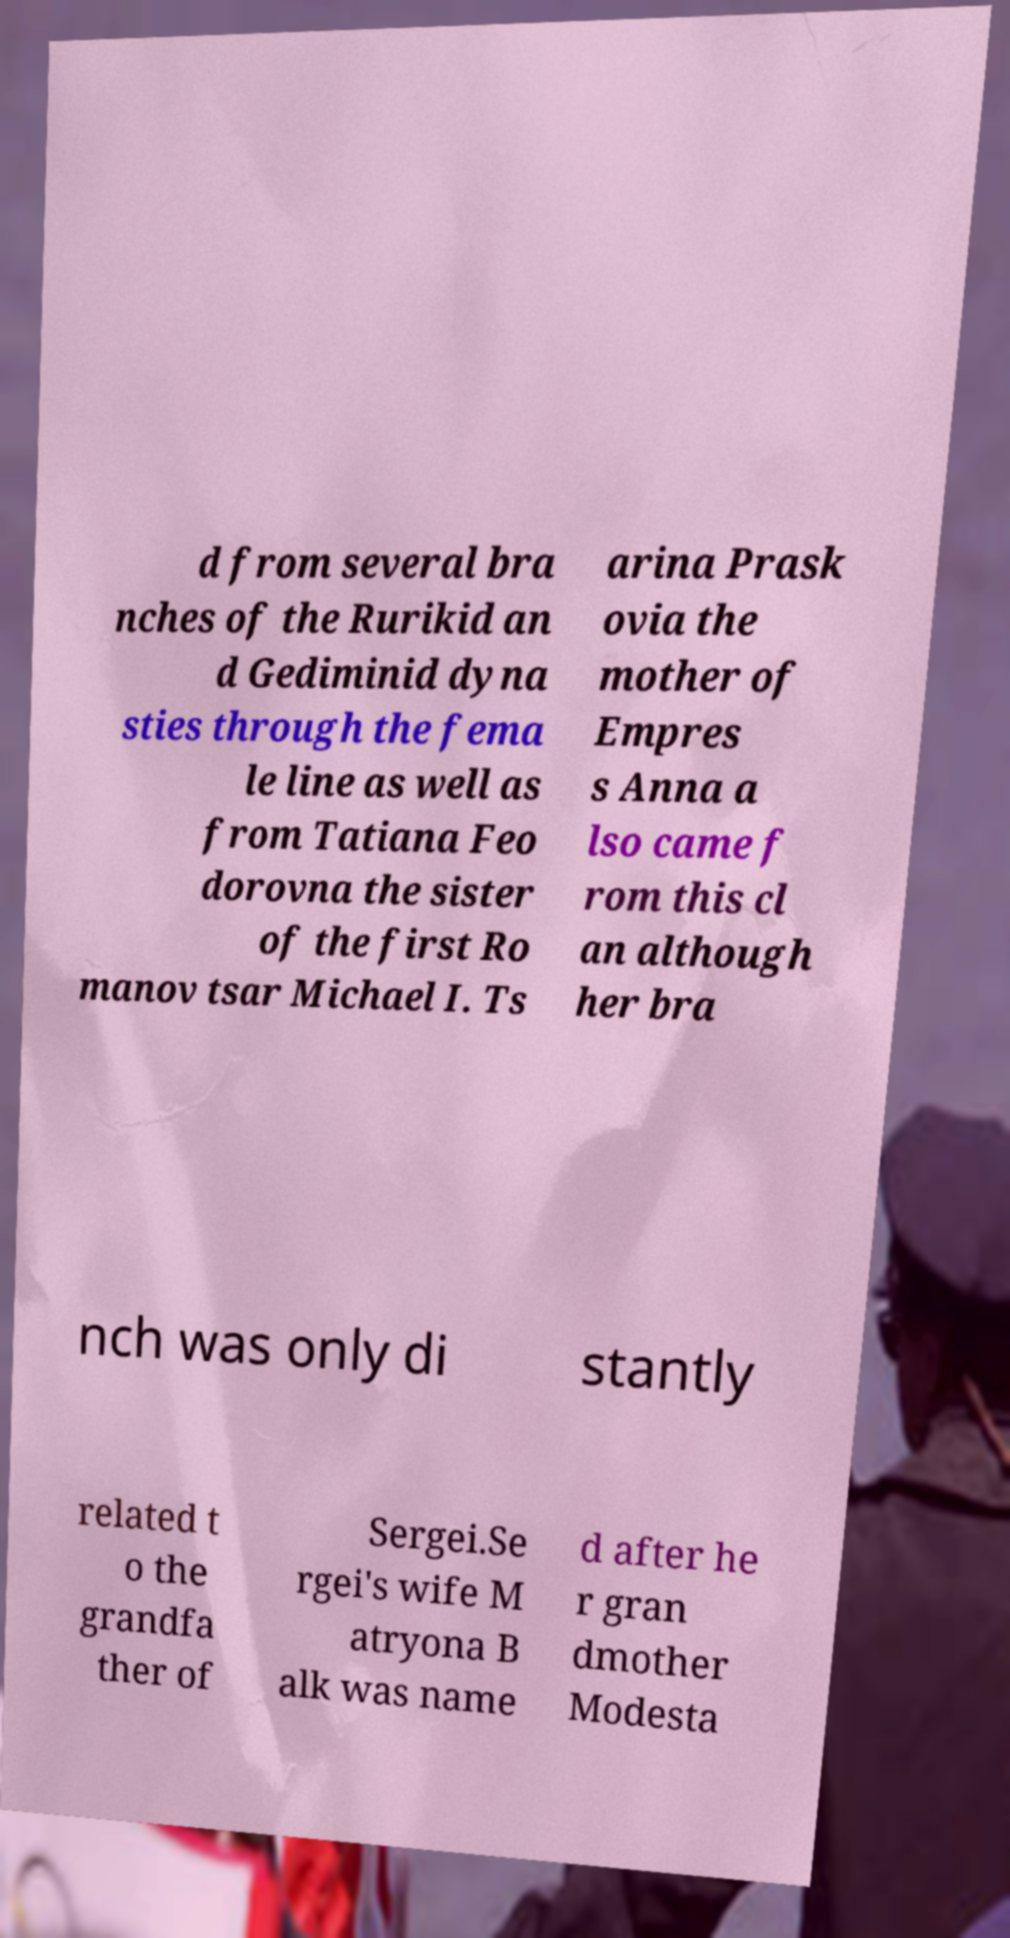There's text embedded in this image that I need extracted. Can you transcribe it verbatim? d from several bra nches of the Rurikid an d Gediminid dyna sties through the fema le line as well as from Tatiana Feo dorovna the sister of the first Ro manov tsar Michael I. Ts arina Prask ovia the mother of Empres s Anna a lso came f rom this cl an although her bra nch was only di stantly related t o the grandfa ther of Sergei.Se rgei's wife M atryona B alk was name d after he r gran dmother Modesta 